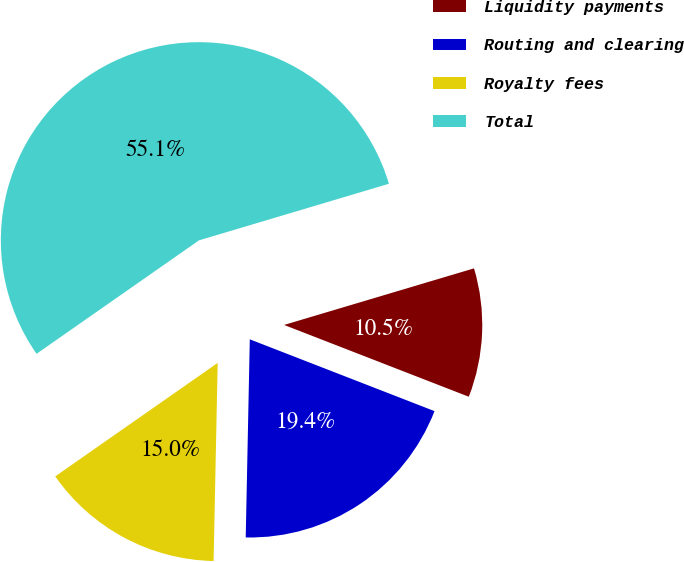Convert chart to OTSL. <chart><loc_0><loc_0><loc_500><loc_500><pie_chart><fcel>Liquidity payments<fcel>Routing and clearing<fcel>Royalty fees<fcel>Total<nl><fcel>10.51%<fcel>19.43%<fcel>14.97%<fcel>55.1%<nl></chart> 